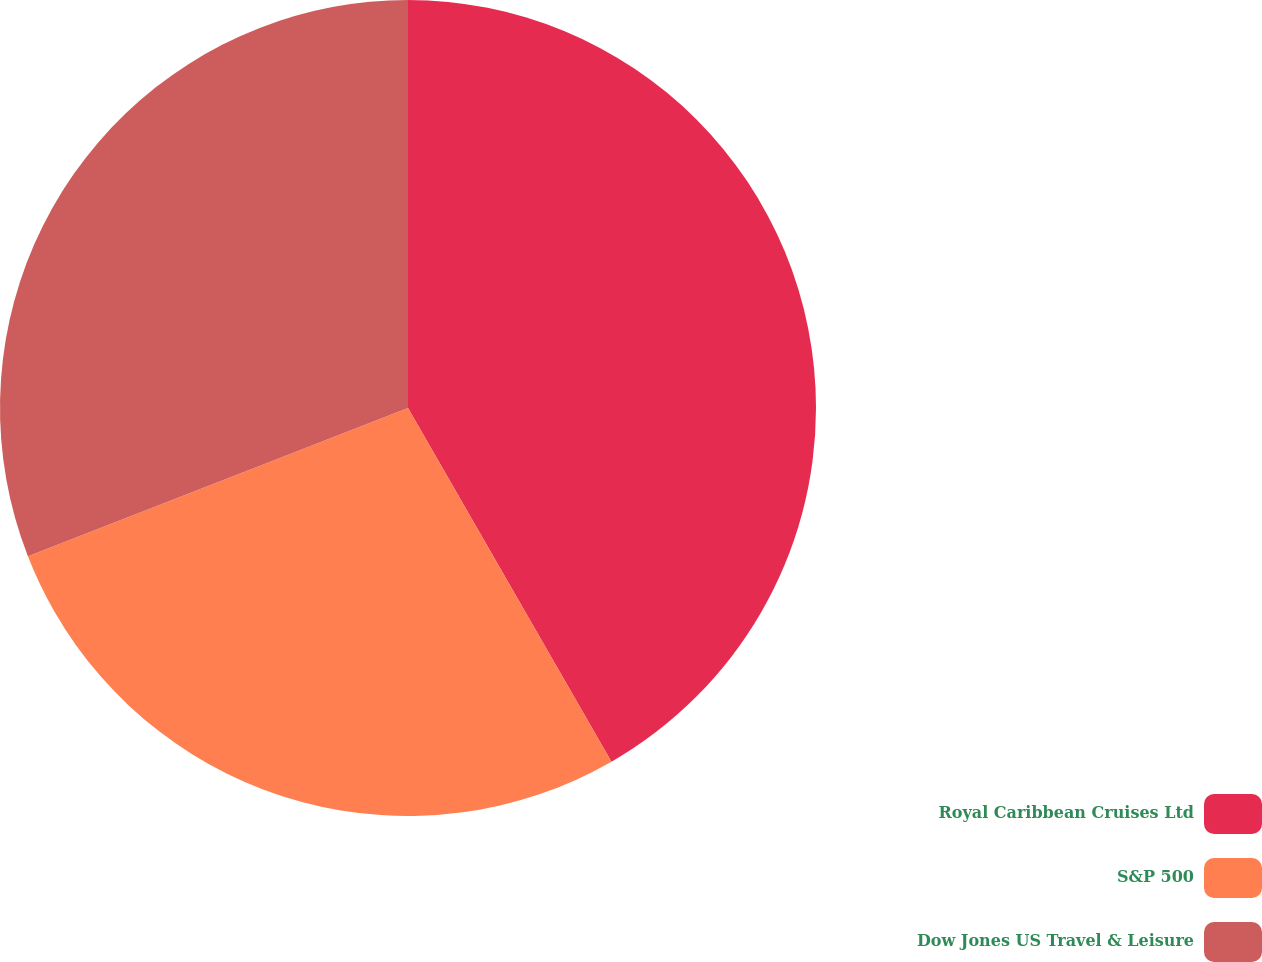Convert chart to OTSL. <chart><loc_0><loc_0><loc_500><loc_500><pie_chart><fcel>Royal Caribbean Cruises Ltd<fcel>S&P 500<fcel>Dow Jones US Travel & Leisure<nl><fcel>41.69%<fcel>27.39%<fcel>30.92%<nl></chart> 